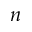<formula> <loc_0><loc_0><loc_500><loc_500>n</formula> 